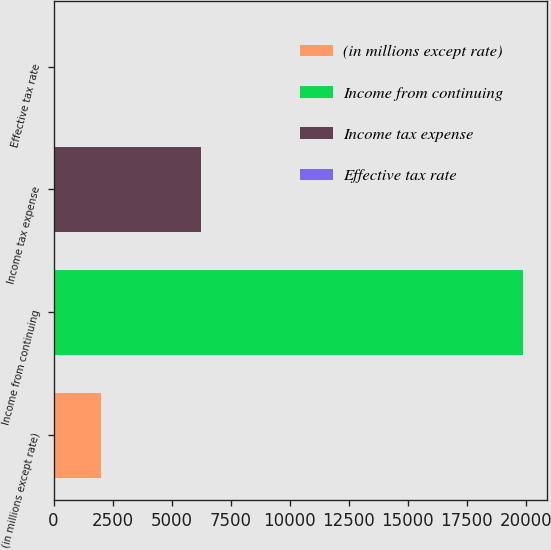Convert chart to OTSL. <chart><loc_0><loc_0><loc_500><loc_500><bar_chart><fcel>(in millions except rate)<fcel>Income from continuing<fcel>Income tax expense<fcel>Effective tax rate<nl><fcel>2016.86<fcel>19886<fcel>6237<fcel>31.4<nl></chart> 